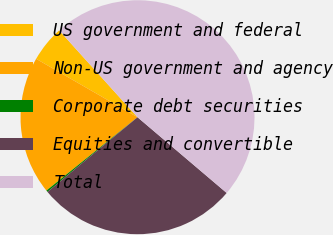<chart> <loc_0><loc_0><loc_500><loc_500><pie_chart><fcel>US government and federal<fcel>Non-US government and agency<fcel>Corporate debt securities<fcel>Equities and convertible<fcel>Total<nl><fcel>5.0%<fcel>19.11%<fcel>0.23%<fcel>27.77%<fcel>47.89%<nl></chart> 